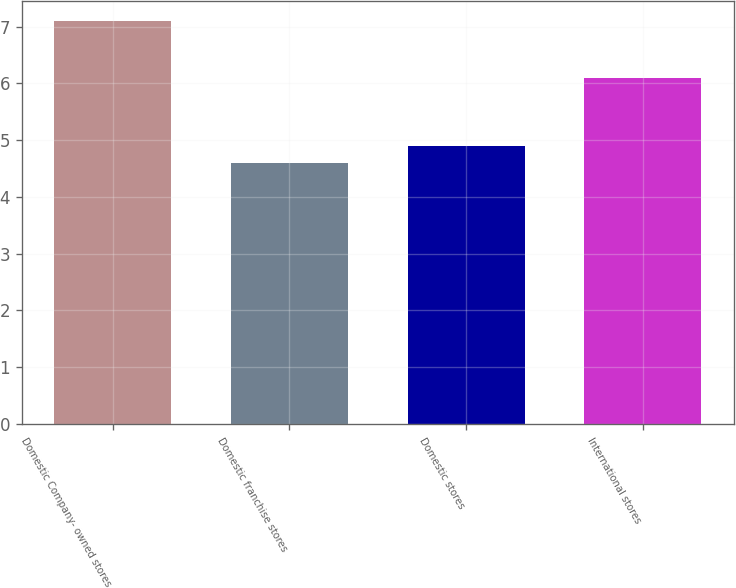Convert chart to OTSL. <chart><loc_0><loc_0><loc_500><loc_500><bar_chart><fcel>Domestic Company- owned stores<fcel>Domestic franchise stores<fcel>Domestic stores<fcel>International stores<nl><fcel>7.1<fcel>4.6<fcel>4.9<fcel>6.1<nl></chart> 